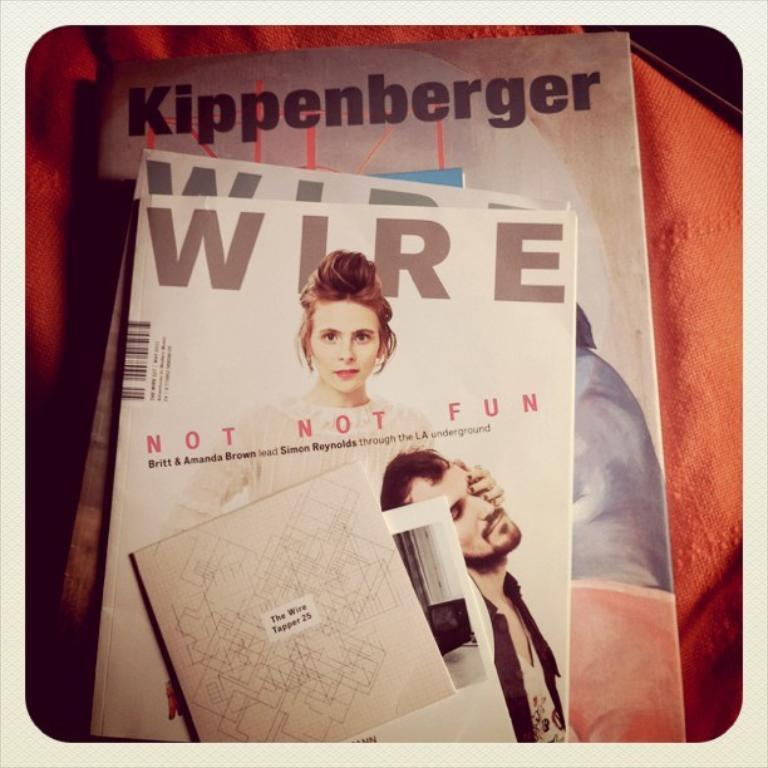What type of reading material is present in the image? There are magazines in the image. What can be found on the magazines? There is text and images on the magazines. Can you describe the images on the magazines? There is an image of a man and an image of a woman on the magazines. What is visible in the background of the image? There is cloth visible in the background of the image. What type of pocket can be seen on the man's clothing in the image? There is no man's clothing visible in the image, as it only shows the images on the magazines. 